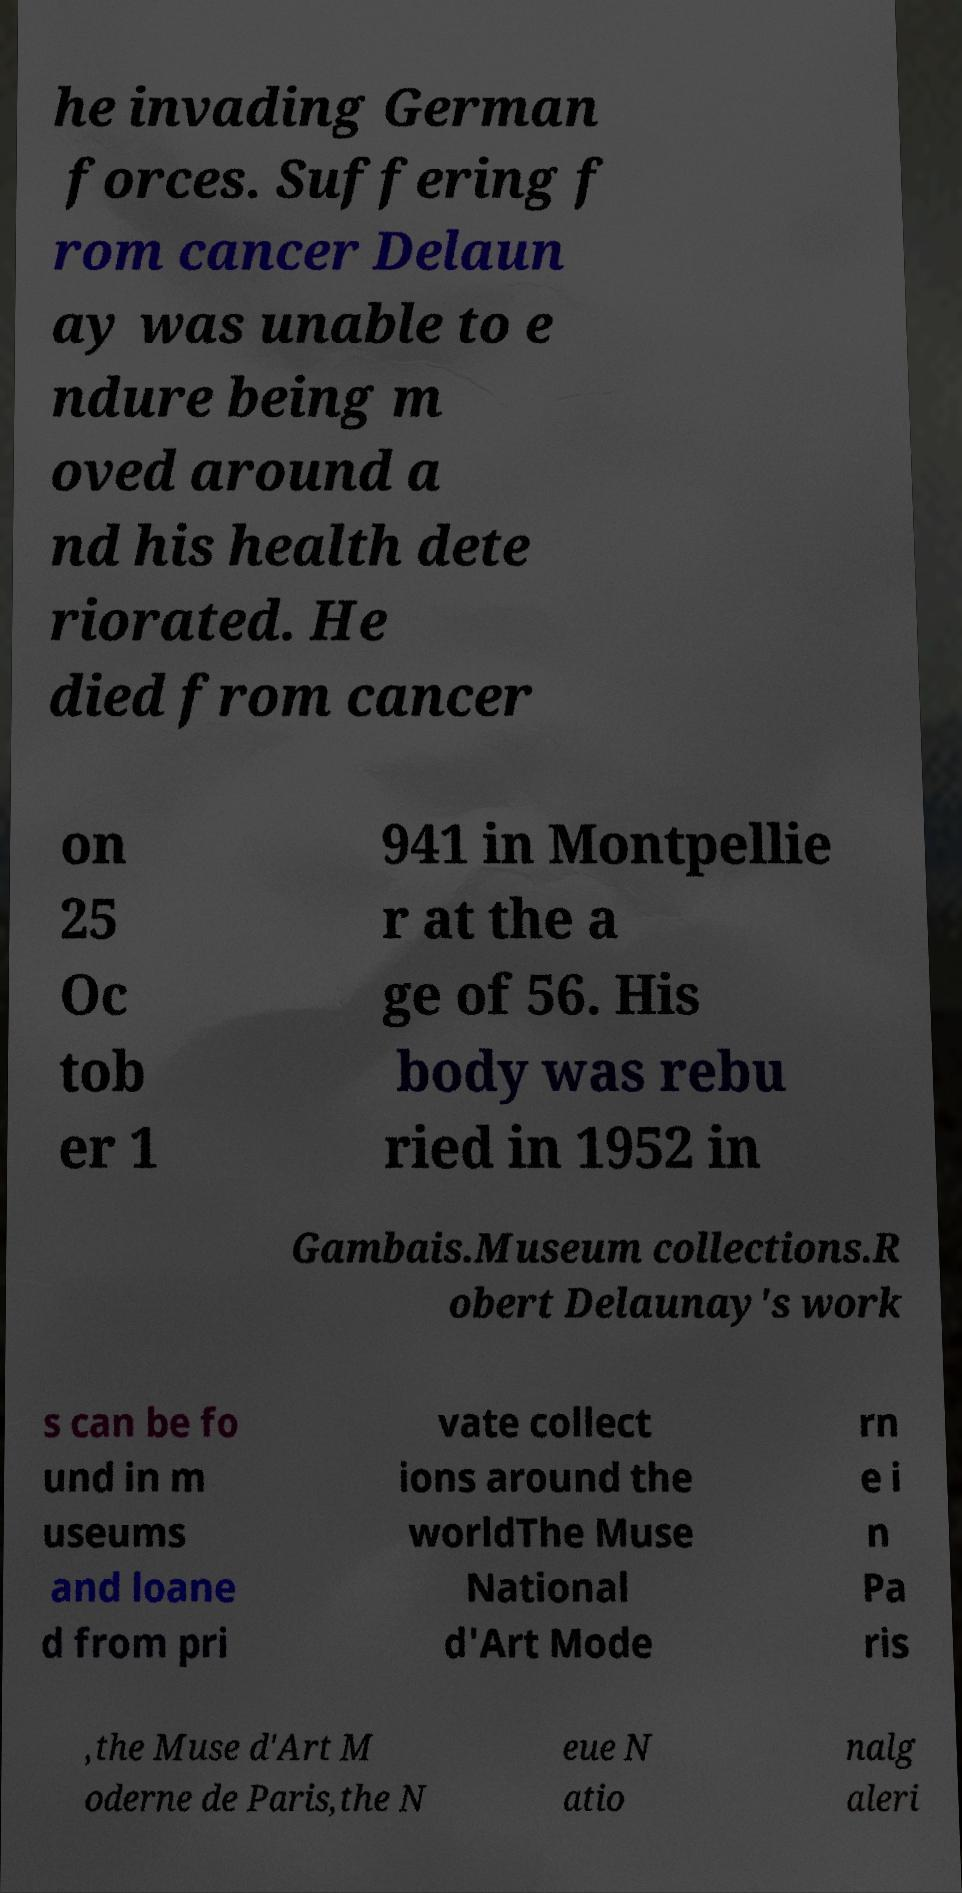Can you read and provide the text displayed in the image?This photo seems to have some interesting text. Can you extract and type it out for me? he invading German forces. Suffering f rom cancer Delaun ay was unable to e ndure being m oved around a nd his health dete riorated. He died from cancer on 25 Oc tob er 1 941 in Montpellie r at the a ge of 56. His body was rebu ried in 1952 in Gambais.Museum collections.R obert Delaunay's work s can be fo und in m useums and loane d from pri vate collect ions around the worldThe Muse National d'Art Mode rn e i n Pa ris ,the Muse d'Art M oderne de Paris,the N eue N atio nalg aleri 